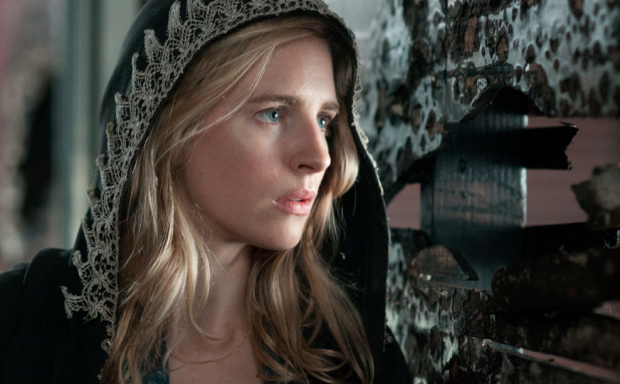What do you think the woman might be thinking about? The woman appears to be deep in thought, possibly contemplating a difficult decision or reflecting on a troubling event. Her expression of concern and the way she looks off to the side suggest she might be recalling a past memory or anticipating a future encounter that is causing her distress. Why does her attire contribute to the mysterious vibe of the scene? Her attire, specifically the black hooded cloak with white lace trim, contributes significantly to the mysterious vibe of the scene. The cloak envelops her, creating an aura of secrecy and enigma. The contrast between the dark cloak and the peeling, monochrome posters behind her enhances this sense of mystery and suspense, suggesting that she is part of a larger, possibly clandestine narrative. 